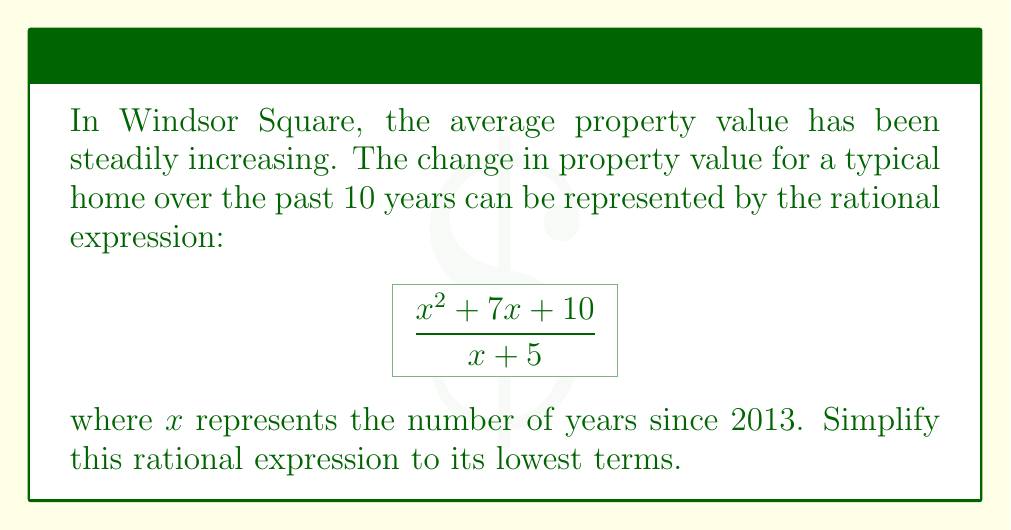Give your solution to this math problem. Let's simplify this rational expression step-by-step:

1) First, we need to factor the numerator and denominator if possible.

   Numerator: $x^2 + 7x + 10$
   This is a quadratic expression. We can factor it using the ac-method:
   $x^2 + 7x + 10 = (x + 5)(x + 2)$

   Denominator: $x + 5$
   This is already in its simplest form.

2) Now our expression looks like this:

   $$\frac{(x + 5)(x + 2)}{x + 5}$$

3) We can cancel out the common factor $(x + 5)$ in the numerator and denominator:

   $$\frac{\cancel{(x + 5)}(x + 2)}{\cancel{x + 5}}$$

4) After cancellation, we're left with:

   $x + 2$

This is the simplified form of the rational expression.
Answer: $x + 2$ 